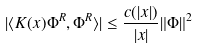<formula> <loc_0><loc_0><loc_500><loc_500>| \langle K ( x ) \Phi ^ { R } , \Phi ^ { R } \rangle | \leq \frac { c ( | x | ) } { | x | } \| \Phi \| ^ { 2 }</formula> 